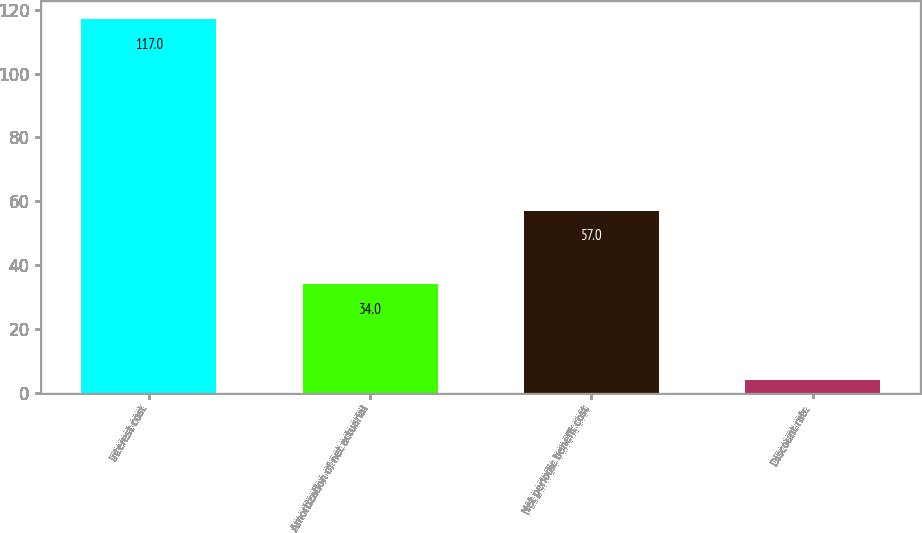Convert chart. <chart><loc_0><loc_0><loc_500><loc_500><bar_chart><fcel>Interest cost<fcel>Amortization of net actuarial<fcel>Net periodic benefit cost<fcel>Discount rate<nl><fcel>117<fcel>34<fcel>57<fcel>4.01<nl></chart> 